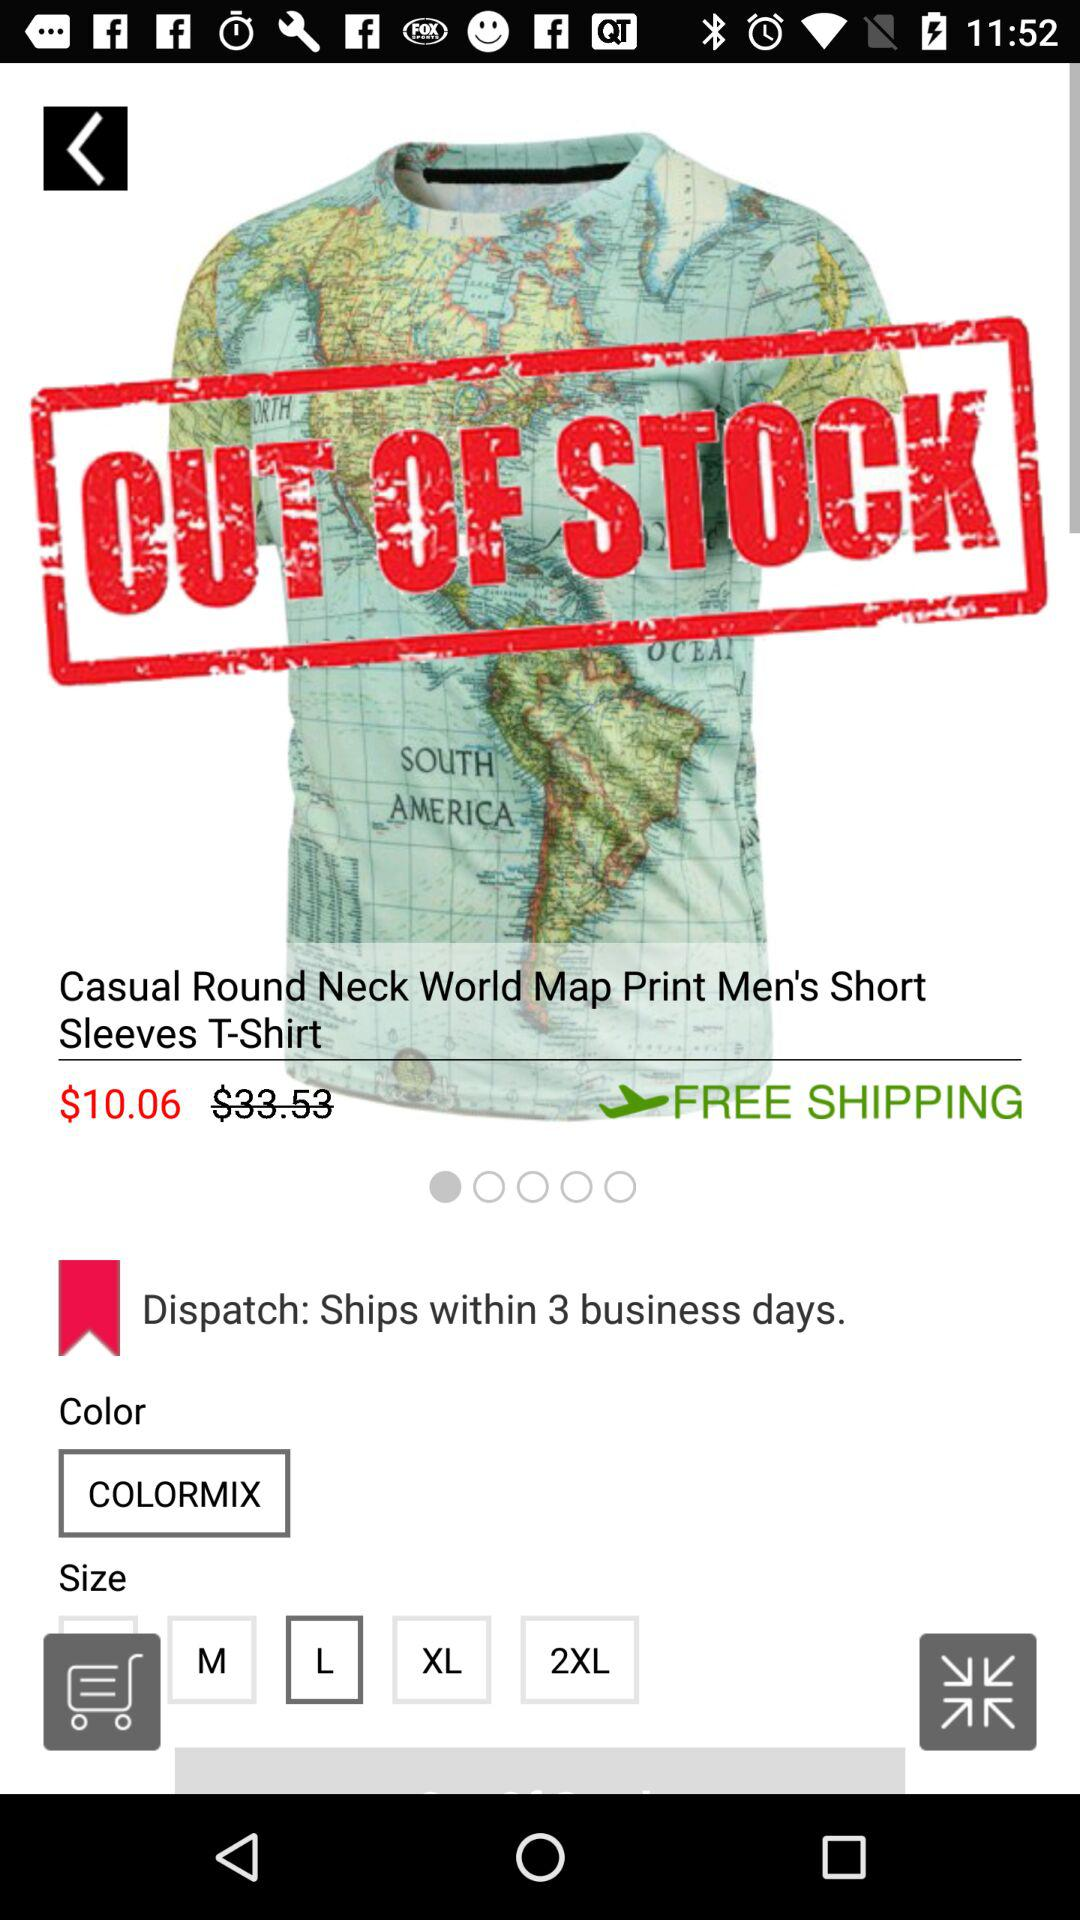What is the selected size? The selected size is large. 